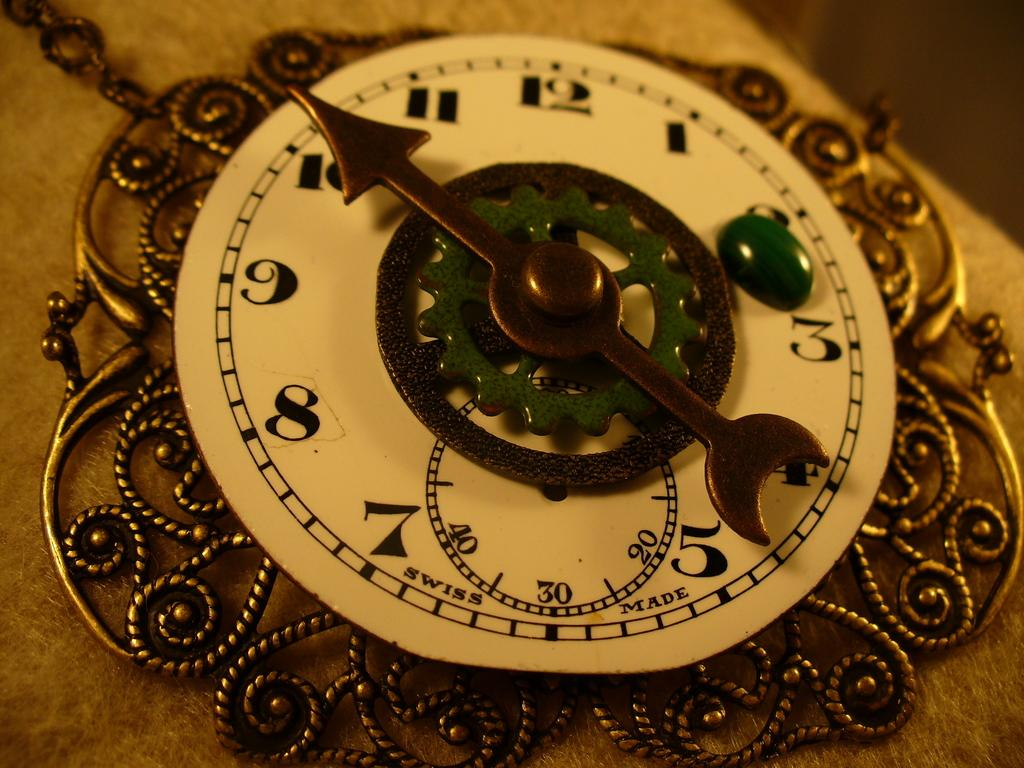<image>
Relay a brief, clear account of the picture shown. A clock says "SWISS MADE" on the face. 